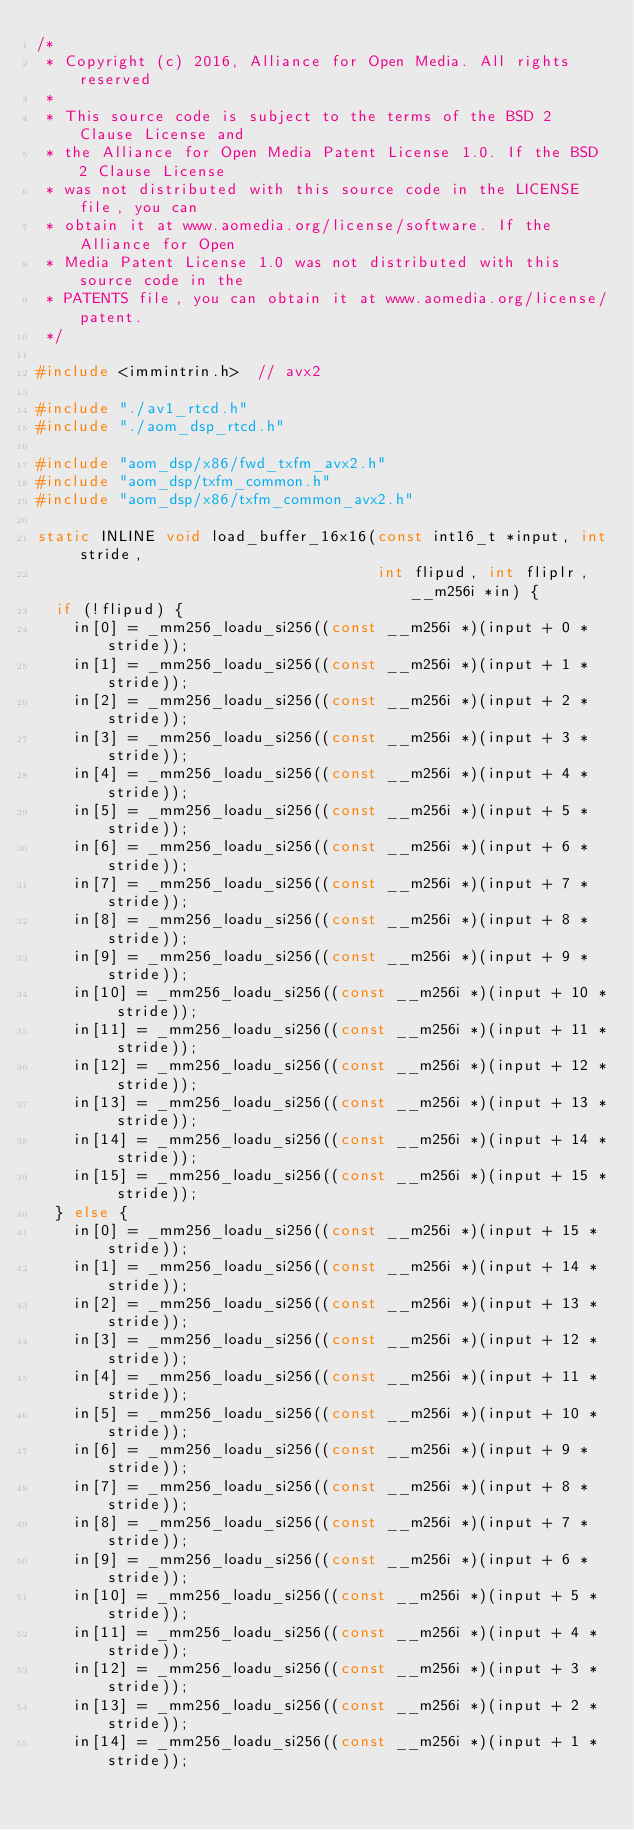Convert code to text. <code><loc_0><loc_0><loc_500><loc_500><_C_>/*
 * Copyright (c) 2016, Alliance for Open Media. All rights reserved
 *
 * This source code is subject to the terms of the BSD 2 Clause License and
 * the Alliance for Open Media Patent License 1.0. If the BSD 2 Clause License
 * was not distributed with this source code in the LICENSE file, you can
 * obtain it at www.aomedia.org/license/software. If the Alliance for Open
 * Media Patent License 1.0 was not distributed with this source code in the
 * PATENTS file, you can obtain it at www.aomedia.org/license/patent.
 */

#include <immintrin.h>  // avx2

#include "./av1_rtcd.h"
#include "./aom_dsp_rtcd.h"

#include "aom_dsp/x86/fwd_txfm_avx2.h"
#include "aom_dsp/txfm_common.h"
#include "aom_dsp/x86/txfm_common_avx2.h"

static INLINE void load_buffer_16x16(const int16_t *input, int stride,
                                     int flipud, int fliplr, __m256i *in) {
  if (!flipud) {
    in[0] = _mm256_loadu_si256((const __m256i *)(input + 0 * stride));
    in[1] = _mm256_loadu_si256((const __m256i *)(input + 1 * stride));
    in[2] = _mm256_loadu_si256((const __m256i *)(input + 2 * stride));
    in[3] = _mm256_loadu_si256((const __m256i *)(input + 3 * stride));
    in[4] = _mm256_loadu_si256((const __m256i *)(input + 4 * stride));
    in[5] = _mm256_loadu_si256((const __m256i *)(input + 5 * stride));
    in[6] = _mm256_loadu_si256((const __m256i *)(input + 6 * stride));
    in[7] = _mm256_loadu_si256((const __m256i *)(input + 7 * stride));
    in[8] = _mm256_loadu_si256((const __m256i *)(input + 8 * stride));
    in[9] = _mm256_loadu_si256((const __m256i *)(input + 9 * stride));
    in[10] = _mm256_loadu_si256((const __m256i *)(input + 10 * stride));
    in[11] = _mm256_loadu_si256((const __m256i *)(input + 11 * stride));
    in[12] = _mm256_loadu_si256((const __m256i *)(input + 12 * stride));
    in[13] = _mm256_loadu_si256((const __m256i *)(input + 13 * stride));
    in[14] = _mm256_loadu_si256((const __m256i *)(input + 14 * stride));
    in[15] = _mm256_loadu_si256((const __m256i *)(input + 15 * stride));
  } else {
    in[0] = _mm256_loadu_si256((const __m256i *)(input + 15 * stride));
    in[1] = _mm256_loadu_si256((const __m256i *)(input + 14 * stride));
    in[2] = _mm256_loadu_si256((const __m256i *)(input + 13 * stride));
    in[3] = _mm256_loadu_si256((const __m256i *)(input + 12 * stride));
    in[4] = _mm256_loadu_si256((const __m256i *)(input + 11 * stride));
    in[5] = _mm256_loadu_si256((const __m256i *)(input + 10 * stride));
    in[6] = _mm256_loadu_si256((const __m256i *)(input + 9 * stride));
    in[7] = _mm256_loadu_si256((const __m256i *)(input + 8 * stride));
    in[8] = _mm256_loadu_si256((const __m256i *)(input + 7 * stride));
    in[9] = _mm256_loadu_si256((const __m256i *)(input + 6 * stride));
    in[10] = _mm256_loadu_si256((const __m256i *)(input + 5 * stride));
    in[11] = _mm256_loadu_si256((const __m256i *)(input + 4 * stride));
    in[12] = _mm256_loadu_si256((const __m256i *)(input + 3 * stride));
    in[13] = _mm256_loadu_si256((const __m256i *)(input + 2 * stride));
    in[14] = _mm256_loadu_si256((const __m256i *)(input + 1 * stride));</code> 